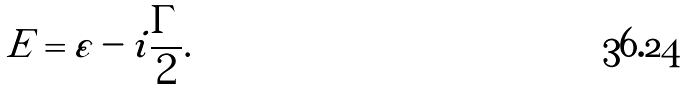Convert formula to latex. <formula><loc_0><loc_0><loc_500><loc_500>E = \varepsilon - i \frac { \Gamma } { 2 } .</formula> 